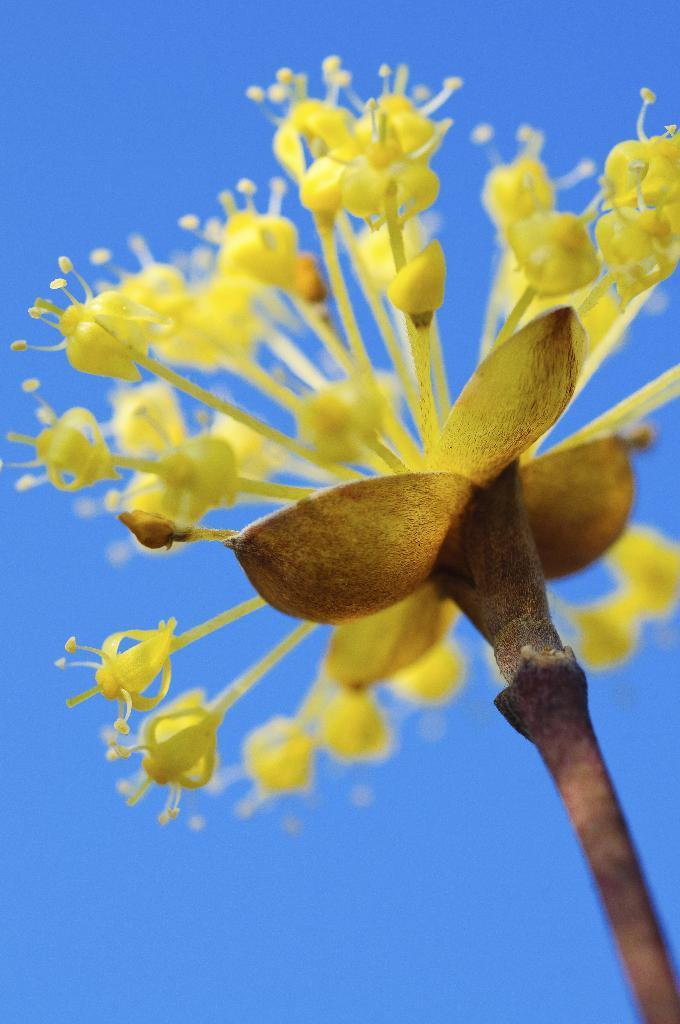In one or two sentences, can you explain what this image depicts? In this picture I can see a flower and I can see blue sky. 